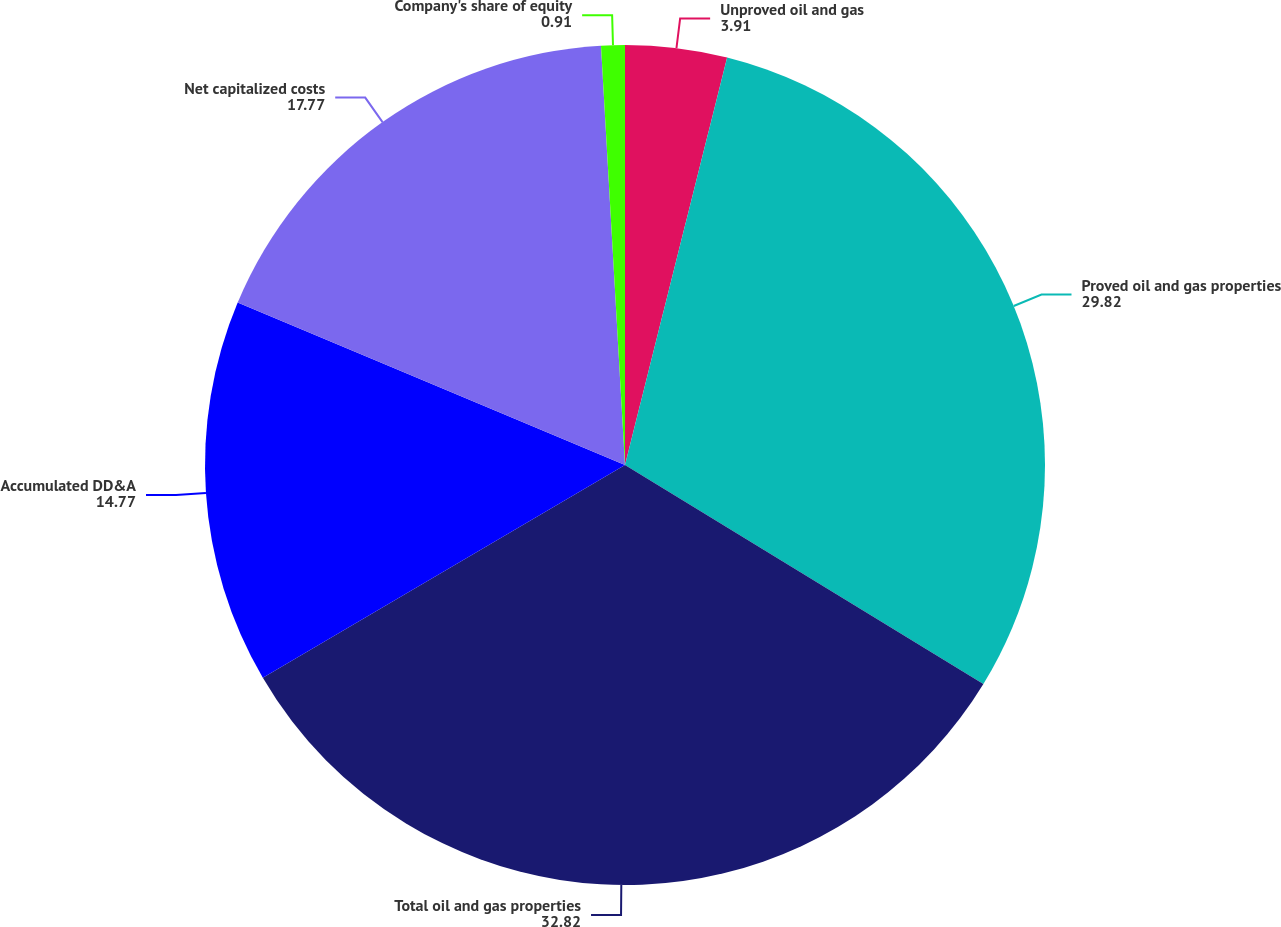Convert chart. <chart><loc_0><loc_0><loc_500><loc_500><pie_chart><fcel>Unproved oil and gas<fcel>Proved oil and gas properties<fcel>Total oil and gas properties<fcel>Accumulated DD&A<fcel>Net capitalized costs<fcel>Company's share of equity<nl><fcel>3.91%<fcel>29.82%<fcel>32.82%<fcel>14.77%<fcel>17.77%<fcel>0.91%<nl></chart> 